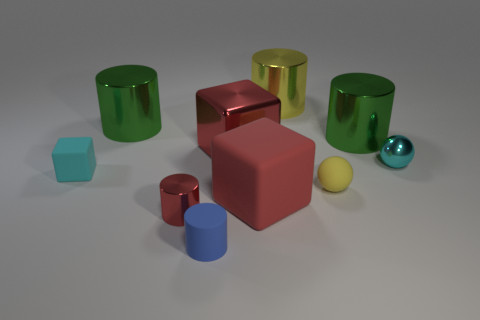Subtract 1 cylinders. How many cylinders are left? 4 Subtract all tiny shiny cylinders. How many cylinders are left? 4 Subtract all yellow cylinders. How many cylinders are left? 4 Subtract all purple cylinders. Subtract all brown balls. How many cylinders are left? 5 Subtract all cubes. How many objects are left? 7 Subtract all big brown shiny things. Subtract all matte cylinders. How many objects are left? 9 Add 6 yellow balls. How many yellow balls are left? 7 Add 8 green balls. How many green balls exist? 8 Subtract 0 gray balls. How many objects are left? 10 